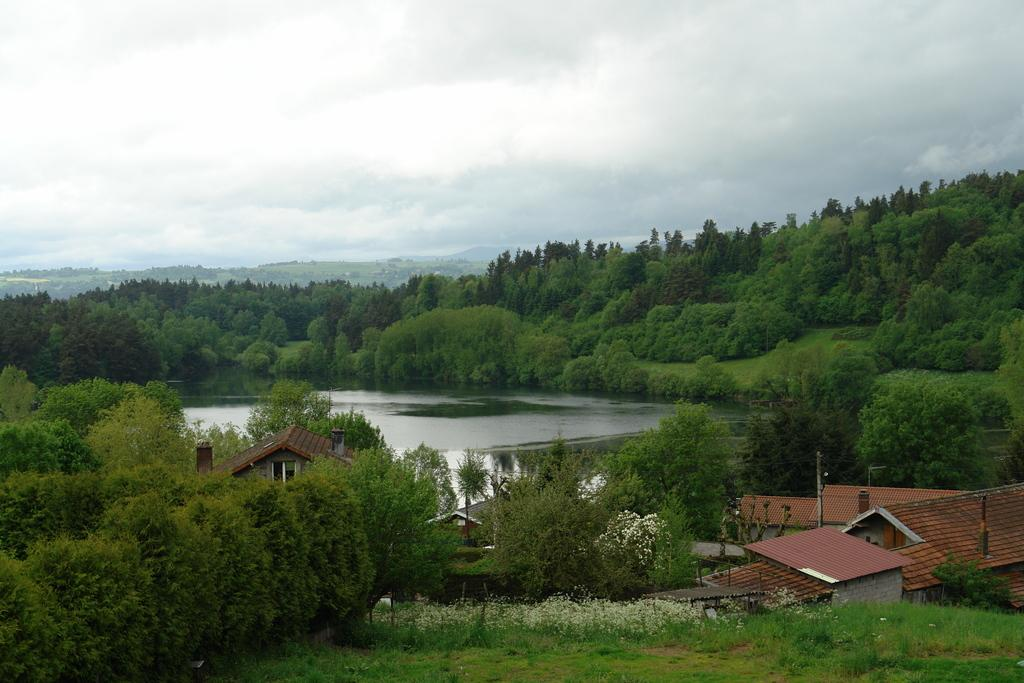What type of vegetation can be seen in the image? There are trees and plants in the image. What type of structures are present in the image? There are houses in the image. What is the condition of the sky in the image? The sky is cloudy in the image. What type of ground cover is visible in the image? There is grass visible in the image. Can you describe any other objects in the image? There are unspecified objects in the image. What type of salt can be seen being used for writing in the image? There is no salt or writing present in the image. What type of tank is visible in the image? There is no tank present in the image. 